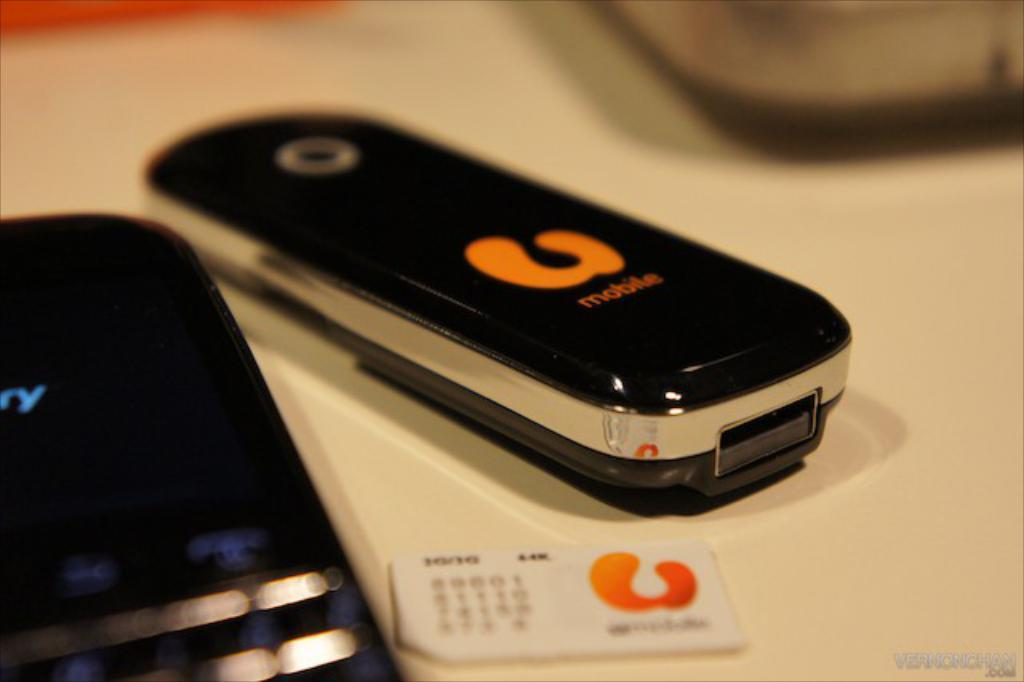<image>
Give a short and clear explanation of the subsequent image. a mobile device that says 'mobile' in orange on it 